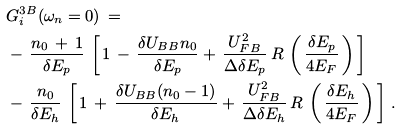Convert formula to latex. <formula><loc_0><loc_0><loc_500><loc_500>\, & \, { G } ^ { 3 B } _ { i } ( \omega _ { n } = 0 ) \, = \\ \, & \, - \, \frac { n _ { 0 } \, + \, 1 } { \delta E _ { p } } \, \left [ \, 1 \, - \, \frac { \delta U _ { B B } n _ { 0 } } { \delta E _ { p } } + \, \frac { U _ { F B } ^ { 2 } } { \Delta \delta E _ { p } } \, R \, \left ( \, \frac { \delta E _ { p } } { 4 E _ { F } } \, \right ) \, \right ] \\ \, & \, - \, \frac { n _ { 0 } } { \delta E _ { h } } \, \left [ \, 1 \, + \, \frac { \delta U _ { B B } ( n _ { 0 } - 1 ) } { \delta E _ { h } } + \, \frac { U _ { F B } ^ { 2 } } { \Delta \delta E _ { h } } \, R \, \left ( \, \frac { \delta E _ { h } } { 4 E _ { F } } \, \right ) \, \right ] \, .</formula> 